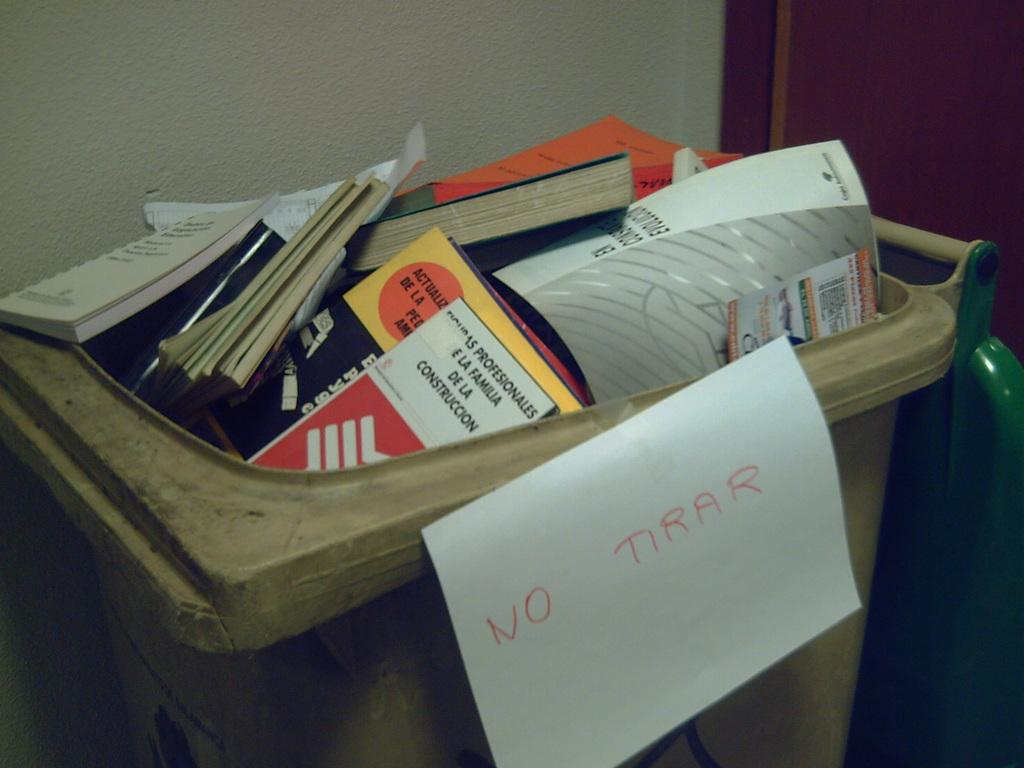<image>
Render a clear and concise summary of the photo. A trashcan with a sign that says No Tirar. 